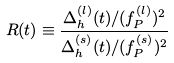Convert formula to latex. <formula><loc_0><loc_0><loc_500><loc_500>R ( t ) \equiv \frac { \Delta _ { h } ^ { ( l ) } ( t ) / ( f _ { P } ^ { ( l ) } ) ^ { 2 } } { \Delta _ { h } ^ { ( s ) } ( t ) / ( f _ { P } ^ { ( s ) } ) ^ { 2 } }</formula> 